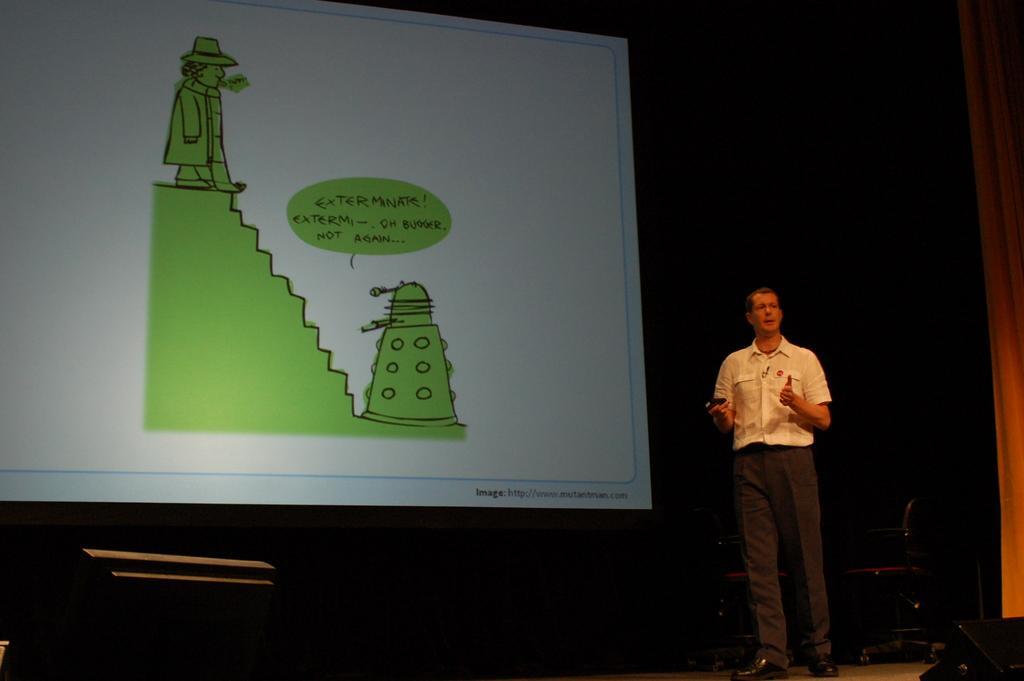In one or two sentences, can you explain what this image depicts? In this image I can see the person standing and the person is wearing white and black color dress. In the background I can see the projection screen. 